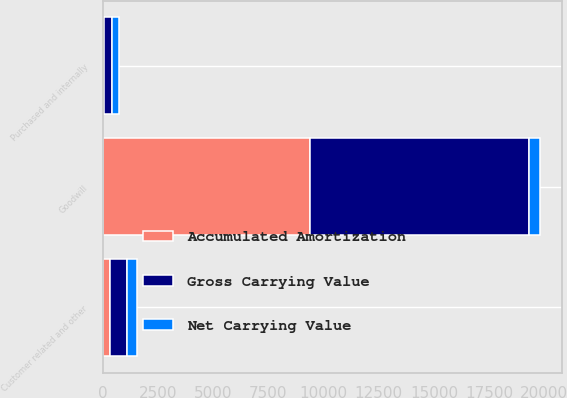Convert chart to OTSL. <chart><loc_0><loc_0><loc_500><loc_500><stacked_bar_chart><ecel><fcel>Goodwill<fcel>Purchased and internally<fcel>Customer related and other<nl><fcel>Gross Carrying Value<fcel>9898.6<fcel>356.4<fcel>763.8<nl><fcel>Net Carrying Value<fcel>514.3<fcel>302.2<fcel>435.2<nl><fcel>Accumulated Amortization<fcel>9384.3<fcel>54.2<fcel>328.6<nl></chart> 